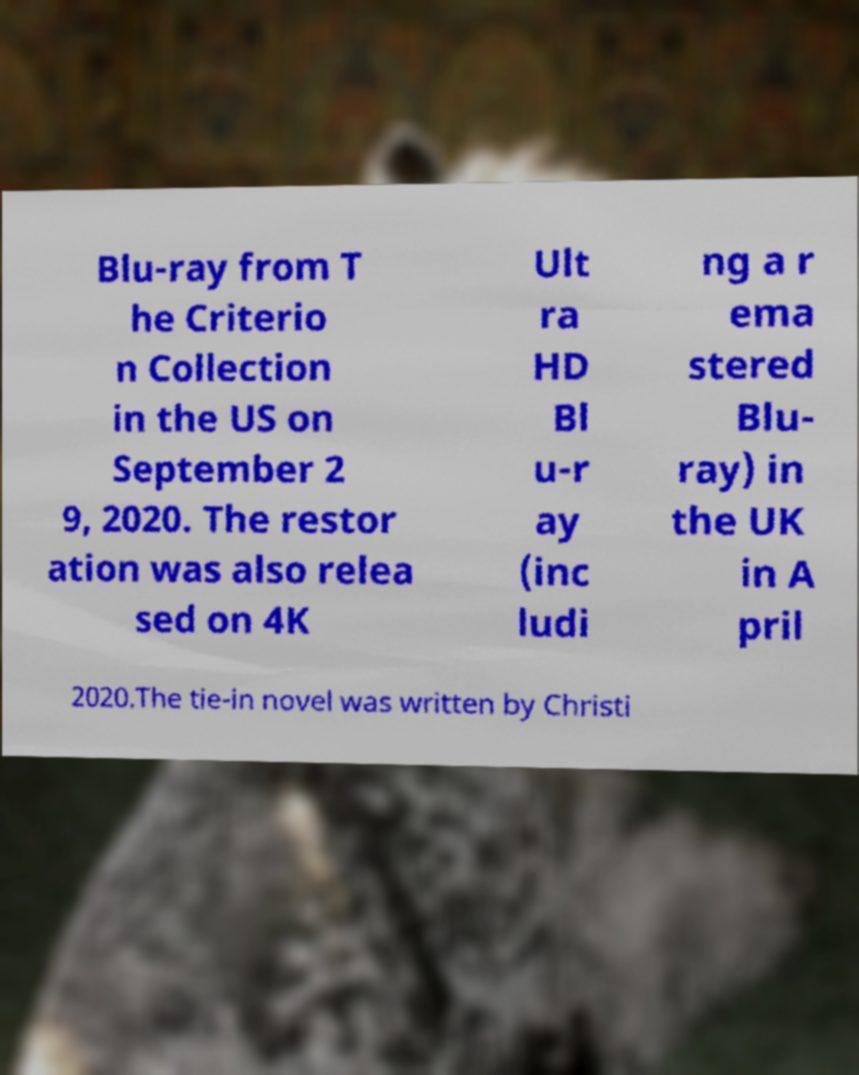Can you read and provide the text displayed in the image?This photo seems to have some interesting text. Can you extract and type it out for me? Blu-ray from T he Criterio n Collection in the US on September 2 9, 2020. The restor ation was also relea sed on 4K Ult ra HD Bl u-r ay (inc ludi ng a r ema stered Blu- ray) in the UK in A pril 2020.The tie-in novel was written by Christi 